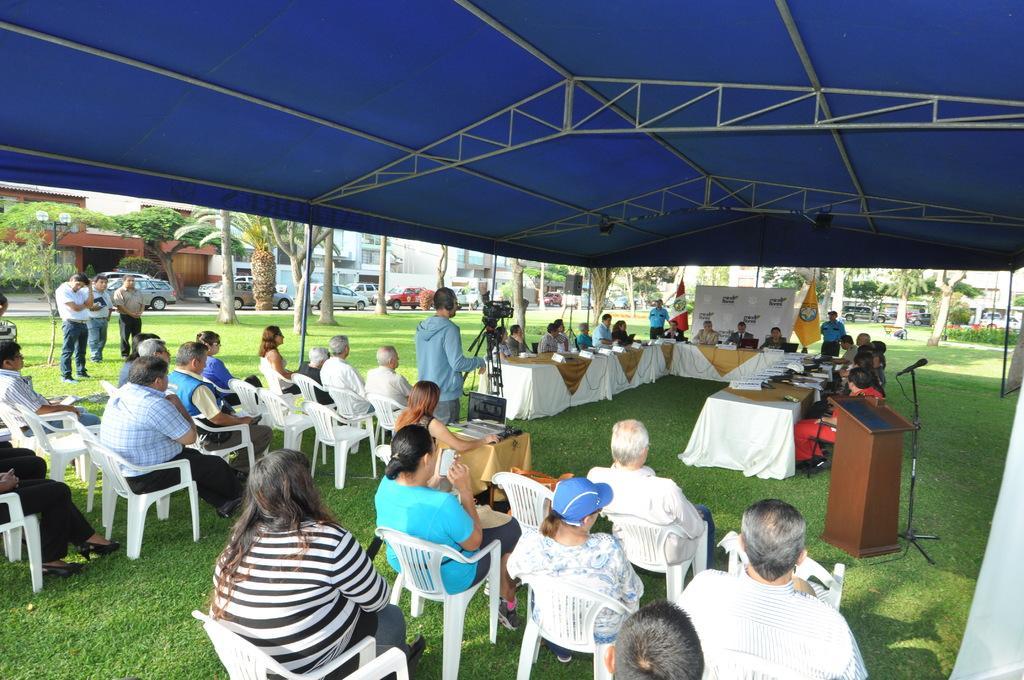Could you give a brief overview of what you see in this image? In this picture I can see group of people sitting on the chairs, there are group of people standing, there are name plates and a laptop on the tables, there is a mike with a mike stand, there is a podium, there is a camera with a tripod stand, there are flags, there are buildings, trees, there are vehicles on the road. 